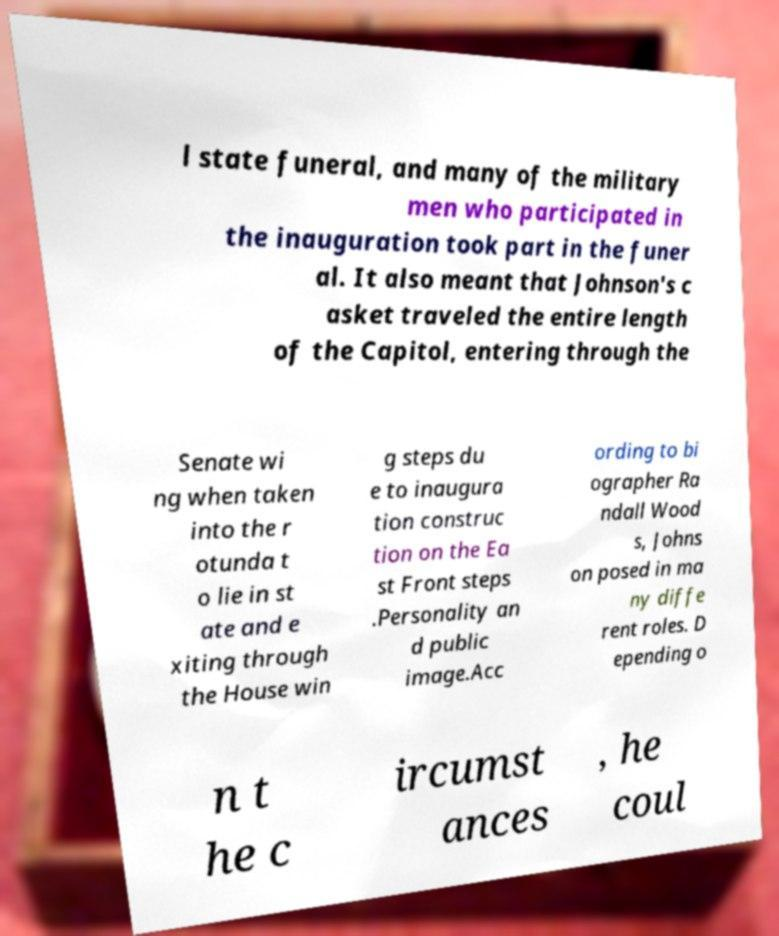Please read and relay the text visible in this image. What does it say? l state funeral, and many of the military men who participated in the inauguration took part in the funer al. It also meant that Johnson's c asket traveled the entire length of the Capitol, entering through the Senate wi ng when taken into the r otunda t o lie in st ate and e xiting through the House win g steps du e to inaugura tion construc tion on the Ea st Front steps .Personality an d public image.Acc ording to bi ographer Ra ndall Wood s, Johns on posed in ma ny diffe rent roles. D epending o n t he c ircumst ances , he coul 